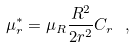<formula> <loc_0><loc_0><loc_500><loc_500>\mu ^ { \ast } _ { r } = \mu _ { R } \frac { R ^ { 2 } } { 2 r ^ { 2 } } C _ { r } \, \ ,</formula> 